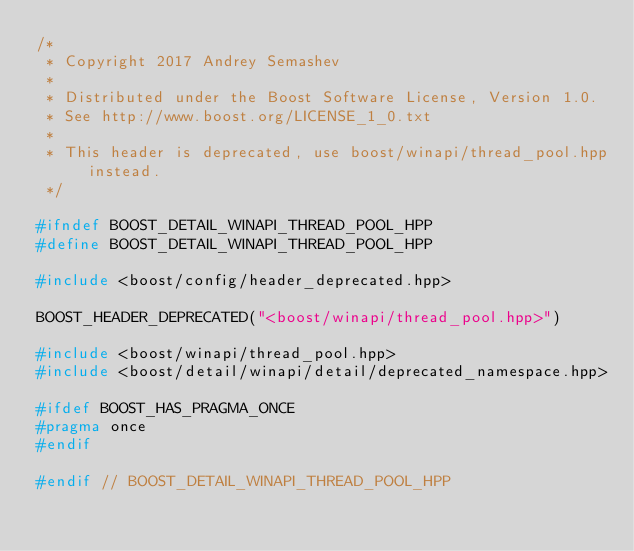<code> <loc_0><loc_0><loc_500><loc_500><_C++_>/*
 * Copyright 2017 Andrey Semashev
 *
 * Distributed under the Boost Software License, Version 1.0.
 * See http://www.boost.org/LICENSE_1_0.txt
 *
 * This header is deprecated, use boost/winapi/thread_pool.hpp instead.
 */

#ifndef BOOST_DETAIL_WINAPI_THREAD_POOL_HPP
#define BOOST_DETAIL_WINAPI_THREAD_POOL_HPP

#include <boost/config/header_deprecated.hpp>

BOOST_HEADER_DEPRECATED("<boost/winapi/thread_pool.hpp>")

#include <boost/winapi/thread_pool.hpp>
#include <boost/detail/winapi/detail/deprecated_namespace.hpp>

#ifdef BOOST_HAS_PRAGMA_ONCE
#pragma once
#endif

#endif // BOOST_DETAIL_WINAPI_THREAD_POOL_HPP
</code> 